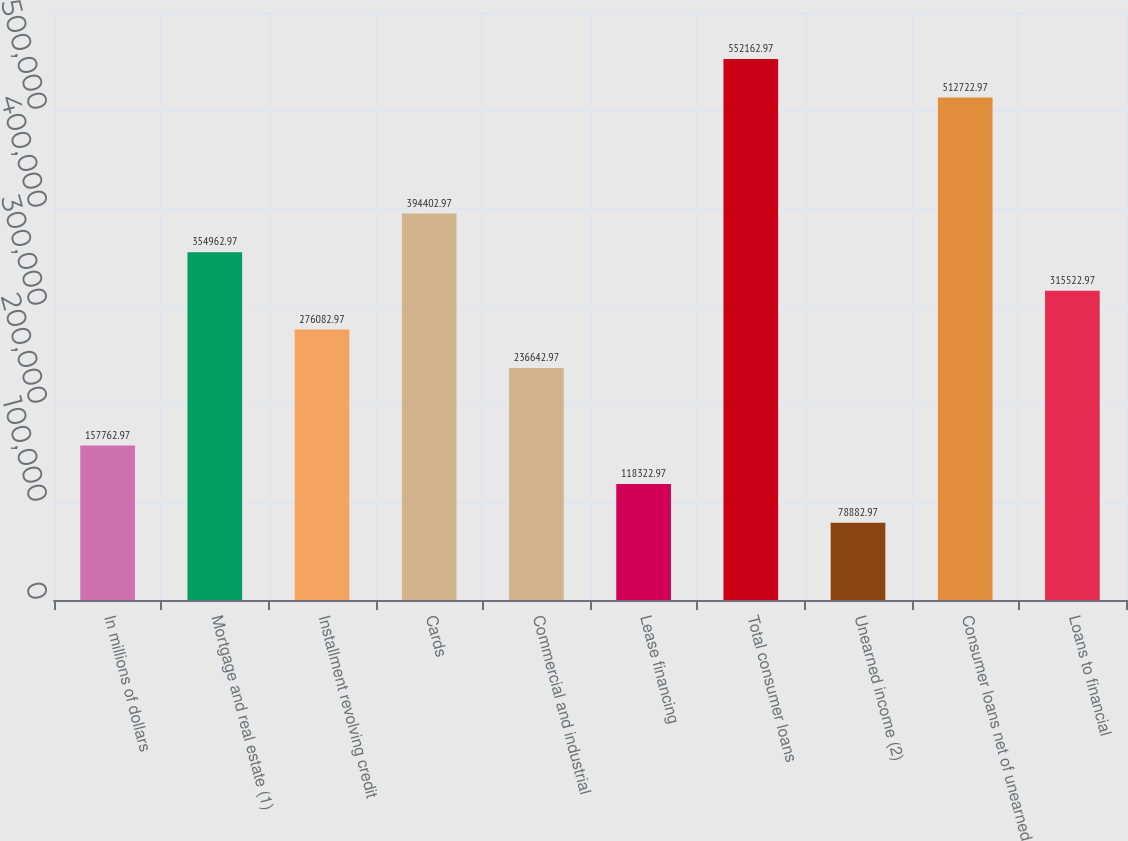Convert chart. <chart><loc_0><loc_0><loc_500><loc_500><bar_chart><fcel>In millions of dollars<fcel>Mortgage and real estate (1)<fcel>Installment revolving credit<fcel>Cards<fcel>Commercial and industrial<fcel>Lease financing<fcel>Total consumer loans<fcel>Unearned income (2)<fcel>Consumer loans net of unearned<fcel>Loans to financial<nl><fcel>157763<fcel>354963<fcel>276083<fcel>394403<fcel>236643<fcel>118323<fcel>552163<fcel>78883<fcel>512723<fcel>315523<nl></chart> 